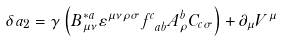<formula> <loc_0><loc_0><loc_500><loc_500>\delta a _ { 2 } = \gamma \left ( B _ { \mu \nu } ^ { * a } \varepsilon ^ { \mu \nu \rho \sigma } f _ { \ a b } ^ { c } A _ { \rho } ^ { b } C _ { c \sigma } \right ) + \partial _ { \mu } V ^ { \mu }</formula> 